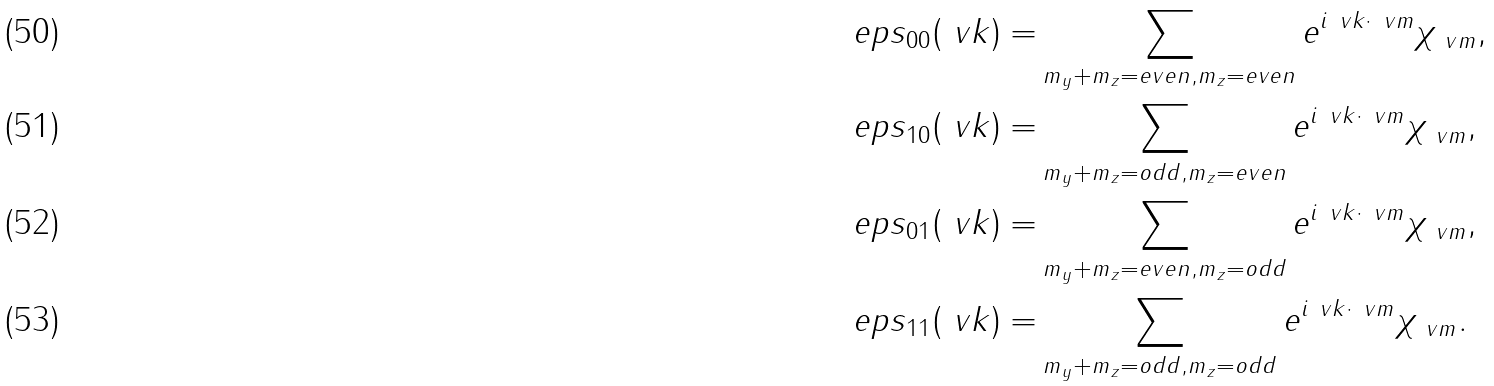Convert formula to latex. <formula><loc_0><loc_0><loc_500><loc_500>\ e p s _ { 0 0 } ( \ v k ) = & \sum _ { m _ { y } + m _ { z } = e v e n , m _ { z } = e v e n } e ^ { i \ v k \cdot \ v m } \chi _ { \ v m } , \\ \ e p s _ { 1 0 } ( \ v k ) = & \sum _ { m _ { y } + m _ { z } = o d d , m _ { z } = e v e n } e ^ { i \ v k \cdot \ v m } \chi _ { \ v m } , \\ \ e p s _ { 0 1 } ( \ v k ) = & \sum _ { m _ { y } + m _ { z } = e v e n , m _ { z } = o d d } e ^ { i \ v k \cdot \ v m } \chi _ { \ v m } , \\ \ e p s _ { 1 1 } ( \ v k ) = & \sum _ { m _ { y } + m _ { z } = o d d , m _ { z } = o d d } e ^ { i \ v k \cdot \ v m } \chi _ { \ v m } .</formula> 